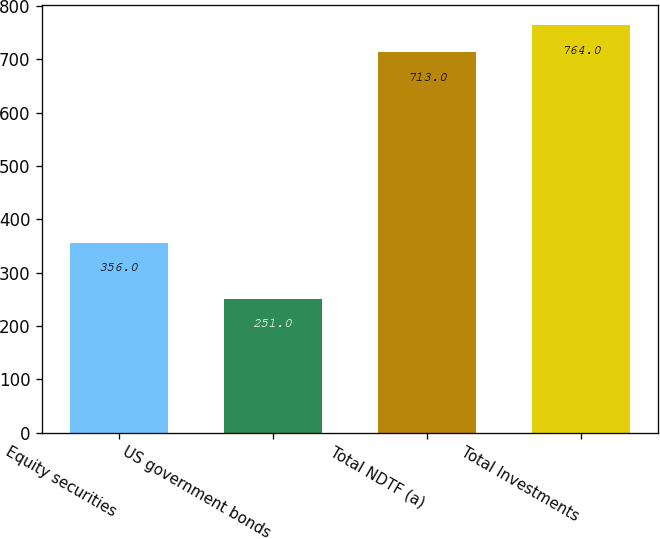<chart> <loc_0><loc_0><loc_500><loc_500><bar_chart><fcel>Equity securities<fcel>US government bonds<fcel>Total NDTF (a)<fcel>Total Investments<nl><fcel>356<fcel>251<fcel>713<fcel>764<nl></chart> 